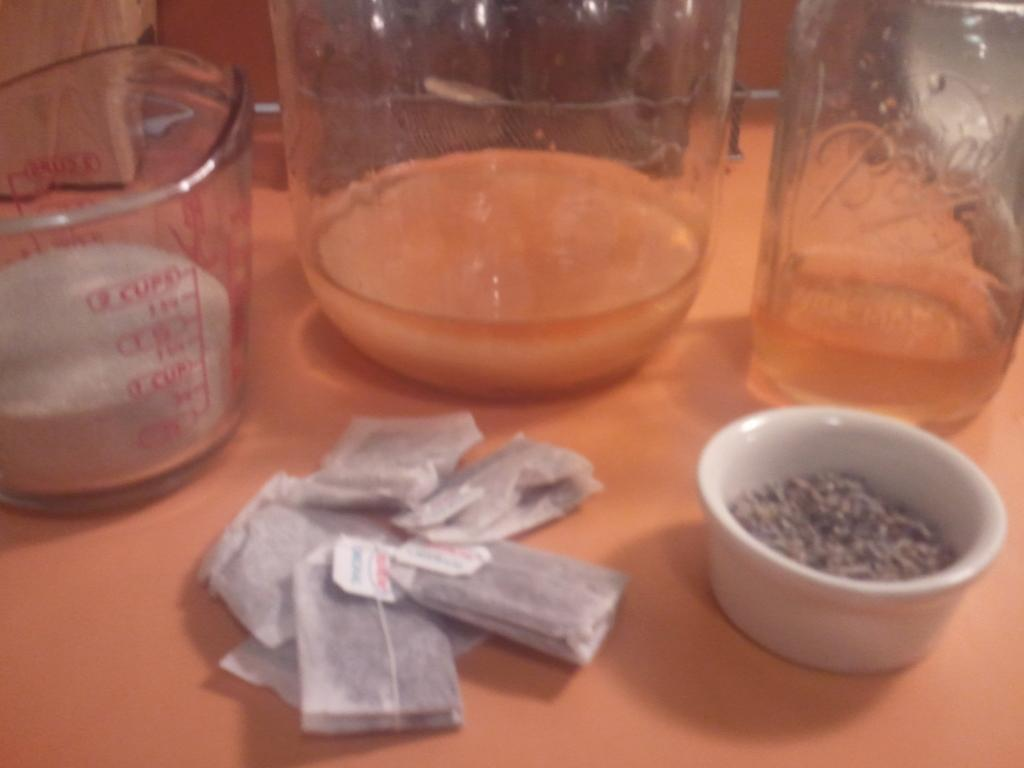<image>
Summarize the visual content of the image. ingredients laid out on a table include a Ball jar and 1 cup of sugar 